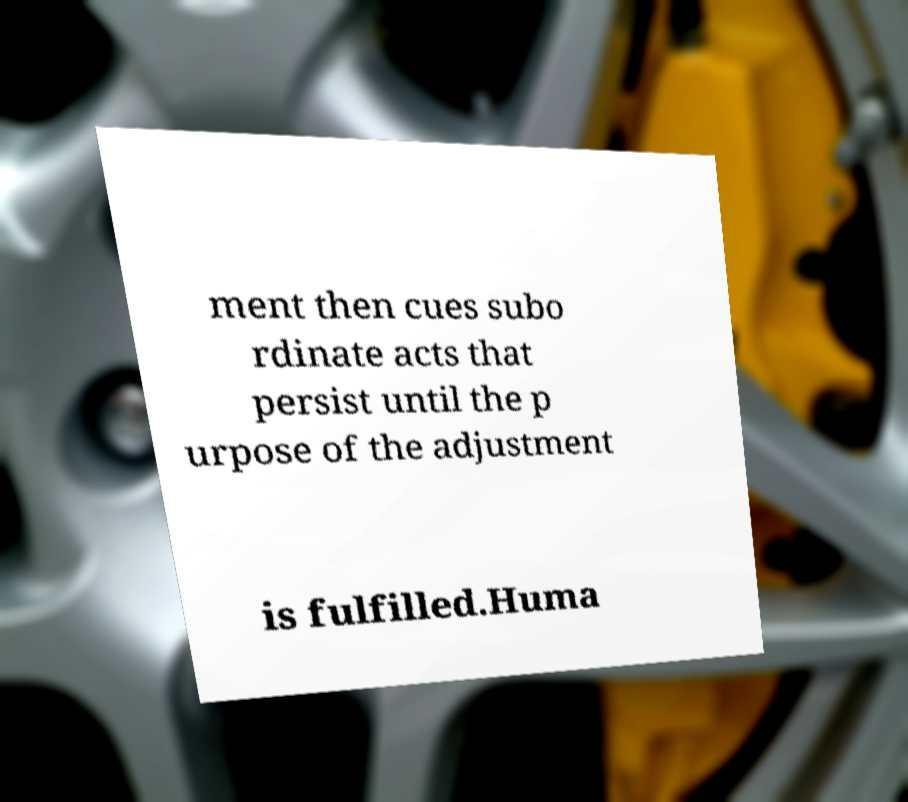Can you accurately transcribe the text from the provided image for me? ment then cues subo rdinate acts that persist until the p urpose of the adjustment is fulfilled.Huma 